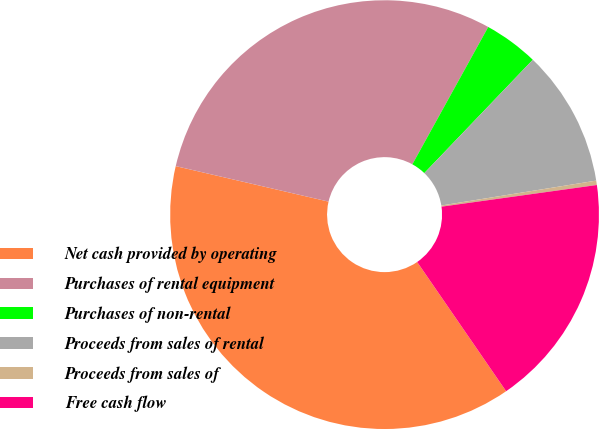Convert chart. <chart><loc_0><loc_0><loc_500><loc_500><pie_chart><fcel>Net cash provided by operating<fcel>Purchases of rental equipment<fcel>Purchases of non-rental<fcel>Proceeds from sales of rental<fcel>Proceeds from sales of<fcel>Free cash flow<nl><fcel>38.23%<fcel>29.4%<fcel>4.12%<fcel>10.31%<fcel>0.33%<fcel>17.61%<nl></chart> 